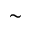<formula> <loc_0><loc_0><loc_500><loc_500>\sim</formula> 